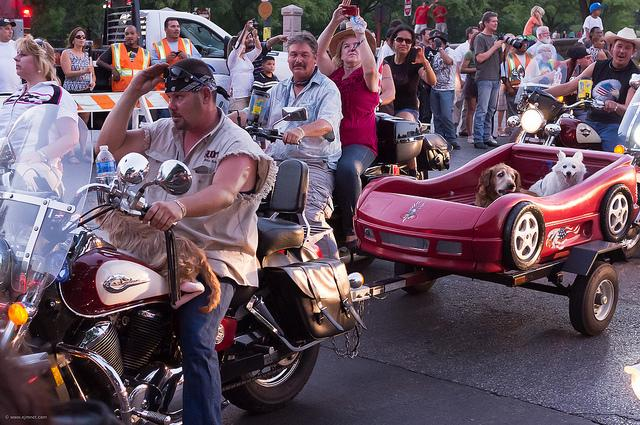The dogs face danger of falling off if the rider does what? Please explain your reasoning. speeds. The dog is exposed. 